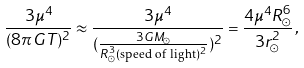<formula> <loc_0><loc_0><loc_500><loc_500>\frac { 3 \mu ^ { 4 } } { ( 8 \pi G T ) ^ { 2 } } \approx \frac { 3 \mu ^ { 4 } } { ( \frac { 3 G M _ { \odot } } { R _ { \odot } ^ { 3 } ( \text {speed of light} ) ^ { 2 } } ) ^ { 2 } } = \frac { 4 \mu ^ { 4 } R _ { \odot } ^ { 6 } } { 3 r _ { \odot } ^ { 2 } } \, ,</formula> 